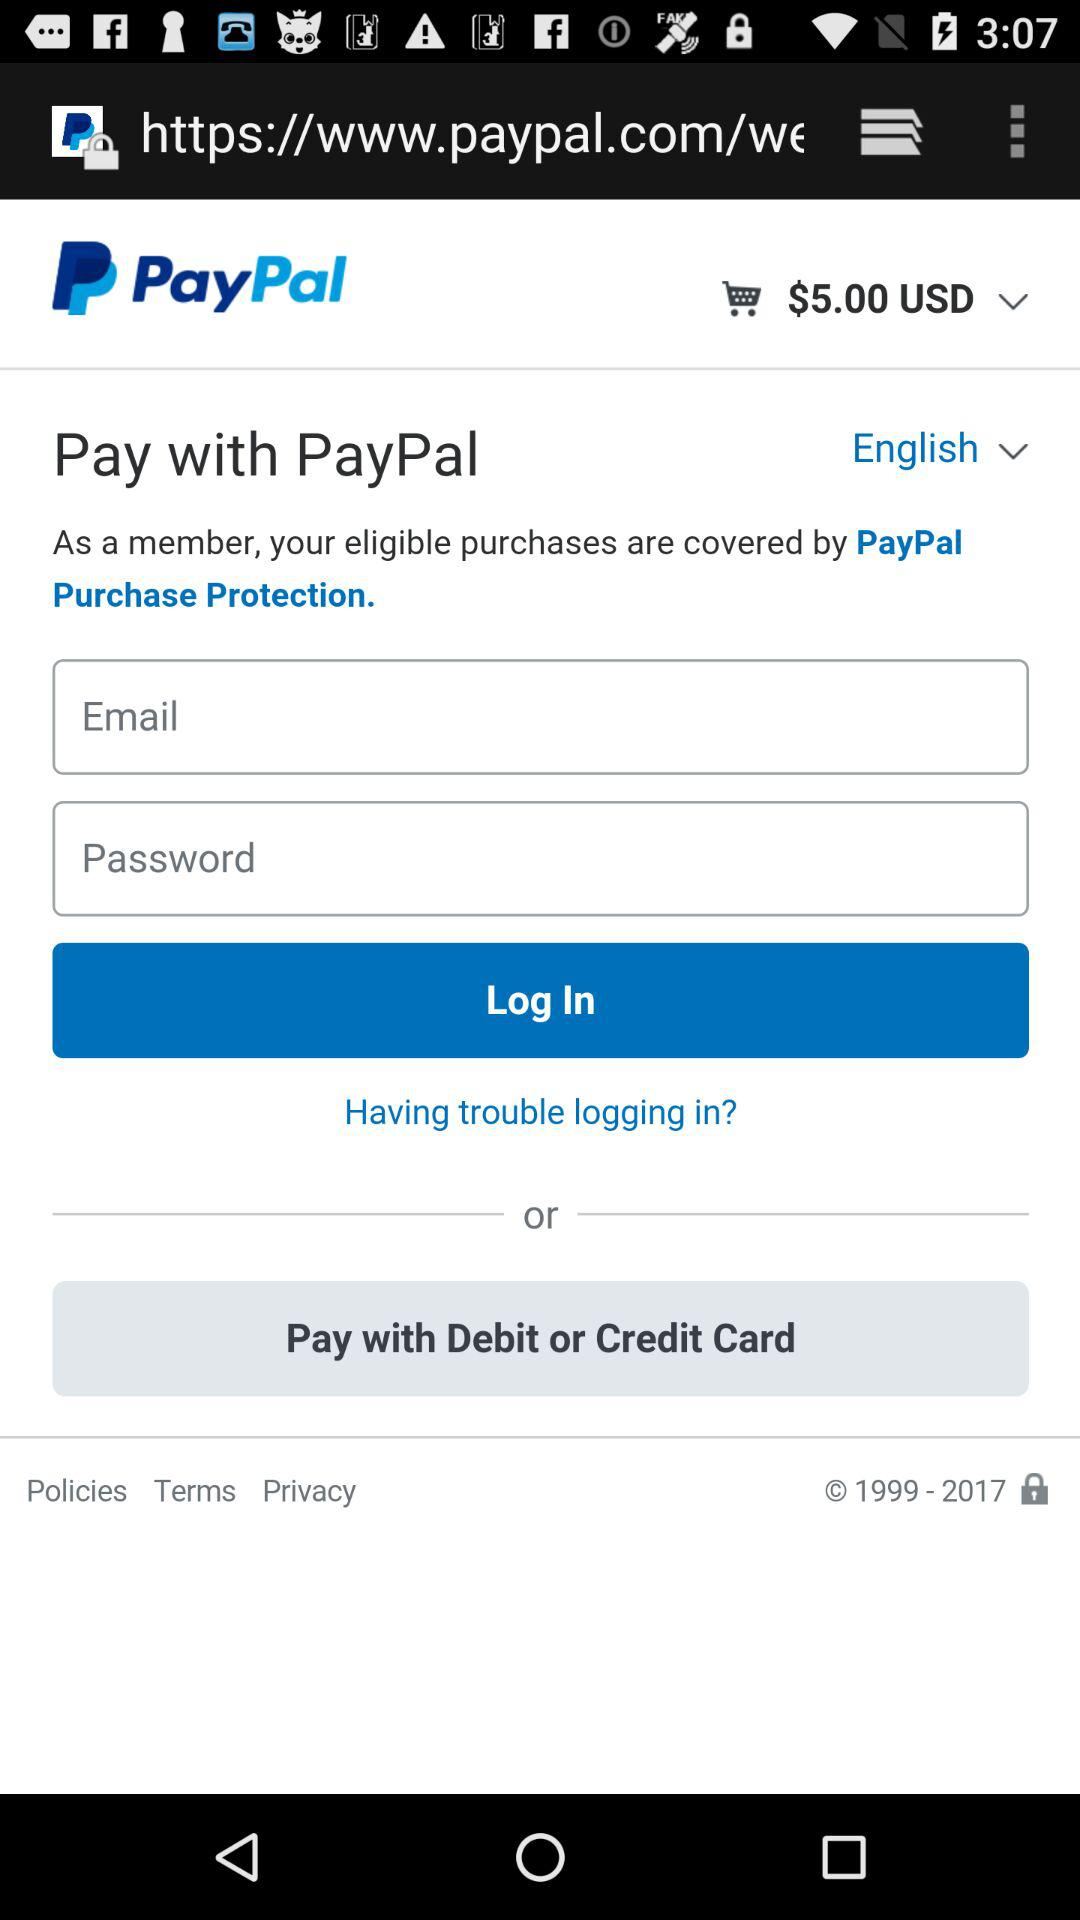What is the selected language? The selected language is "English". 